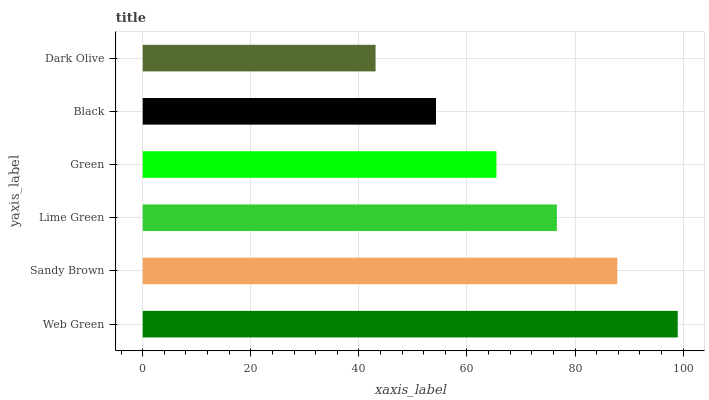Is Dark Olive the minimum?
Answer yes or no. Yes. Is Web Green the maximum?
Answer yes or no. Yes. Is Sandy Brown the minimum?
Answer yes or no. No. Is Sandy Brown the maximum?
Answer yes or no. No. Is Web Green greater than Sandy Brown?
Answer yes or no. Yes. Is Sandy Brown less than Web Green?
Answer yes or no. Yes. Is Sandy Brown greater than Web Green?
Answer yes or no. No. Is Web Green less than Sandy Brown?
Answer yes or no. No. Is Lime Green the high median?
Answer yes or no. Yes. Is Green the low median?
Answer yes or no. Yes. Is Sandy Brown the high median?
Answer yes or no. No. Is Sandy Brown the low median?
Answer yes or no. No. 